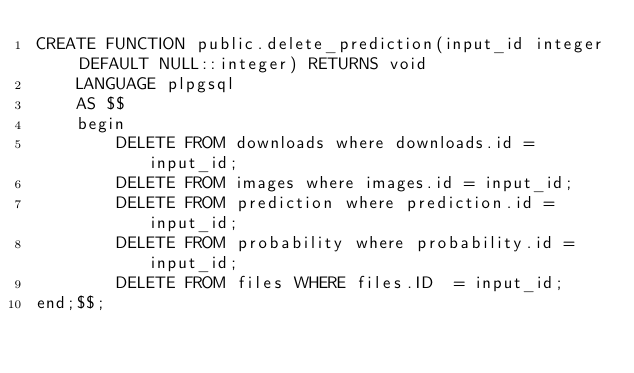<code> <loc_0><loc_0><loc_500><loc_500><_SQL_>CREATE FUNCTION public.delete_prediction(input_id integer DEFAULT NULL::integer) RETURNS void
    LANGUAGE plpgsql
    AS $$
	begin
		DELETE FROM downloads where downloads.id = input_id;
		DELETE FROM images where images.id = input_id;
		DELETE FROM prediction where prediction.id = input_id;
		DELETE FROM probability where probability.id = input_id;
		DELETE FROM files WHERE files.ID  = input_id;
end;$$;</code> 